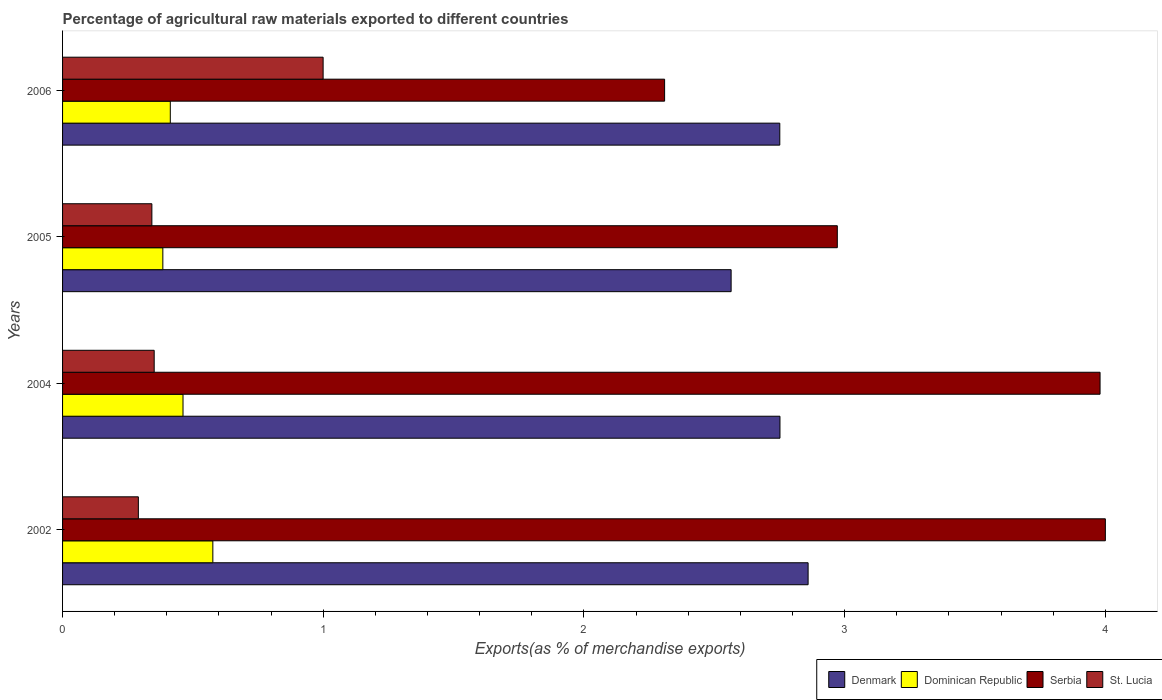How many different coloured bars are there?
Give a very brief answer. 4. Are the number of bars on each tick of the Y-axis equal?
Keep it short and to the point. Yes. How many bars are there on the 1st tick from the top?
Give a very brief answer. 4. What is the label of the 4th group of bars from the top?
Your answer should be compact. 2002. What is the percentage of exports to different countries in Dominican Republic in 2006?
Offer a very short reply. 0.41. Across all years, what is the maximum percentage of exports to different countries in Dominican Republic?
Provide a succinct answer. 0.58. Across all years, what is the minimum percentage of exports to different countries in Denmark?
Provide a short and direct response. 2.56. In which year was the percentage of exports to different countries in Serbia maximum?
Provide a succinct answer. 2002. In which year was the percentage of exports to different countries in Serbia minimum?
Give a very brief answer. 2006. What is the total percentage of exports to different countries in Serbia in the graph?
Offer a very short reply. 13.26. What is the difference between the percentage of exports to different countries in Serbia in 2004 and that in 2006?
Your answer should be very brief. 1.67. What is the difference between the percentage of exports to different countries in Dominican Republic in 2005 and the percentage of exports to different countries in St. Lucia in 2002?
Make the answer very short. 0.09. What is the average percentage of exports to different countries in Dominican Republic per year?
Keep it short and to the point. 0.46. In the year 2004, what is the difference between the percentage of exports to different countries in Dominican Republic and percentage of exports to different countries in St. Lucia?
Make the answer very short. 0.11. What is the ratio of the percentage of exports to different countries in St. Lucia in 2002 to that in 2004?
Provide a short and direct response. 0.83. Is the percentage of exports to different countries in Dominican Republic in 2004 less than that in 2005?
Keep it short and to the point. No. What is the difference between the highest and the second highest percentage of exports to different countries in Denmark?
Your answer should be compact. 0.11. What is the difference between the highest and the lowest percentage of exports to different countries in Serbia?
Make the answer very short. 1.69. What does the 1st bar from the top in 2006 represents?
Your answer should be very brief. St. Lucia. Is it the case that in every year, the sum of the percentage of exports to different countries in Denmark and percentage of exports to different countries in Serbia is greater than the percentage of exports to different countries in Dominican Republic?
Your answer should be compact. Yes. Are all the bars in the graph horizontal?
Your response must be concise. Yes. How many years are there in the graph?
Your answer should be very brief. 4. Are the values on the major ticks of X-axis written in scientific E-notation?
Provide a short and direct response. No. Does the graph contain any zero values?
Your response must be concise. No. Does the graph contain grids?
Keep it short and to the point. No. Where does the legend appear in the graph?
Your answer should be very brief. Bottom right. How many legend labels are there?
Offer a very short reply. 4. How are the legend labels stacked?
Keep it short and to the point. Horizontal. What is the title of the graph?
Keep it short and to the point. Percentage of agricultural raw materials exported to different countries. What is the label or title of the X-axis?
Your answer should be very brief. Exports(as % of merchandise exports). What is the label or title of the Y-axis?
Your answer should be compact. Years. What is the Exports(as % of merchandise exports) of Denmark in 2002?
Offer a very short reply. 2.86. What is the Exports(as % of merchandise exports) in Dominican Republic in 2002?
Give a very brief answer. 0.58. What is the Exports(as % of merchandise exports) in Serbia in 2002?
Keep it short and to the point. 4. What is the Exports(as % of merchandise exports) of St. Lucia in 2002?
Offer a terse response. 0.29. What is the Exports(as % of merchandise exports) in Denmark in 2004?
Ensure brevity in your answer.  2.75. What is the Exports(as % of merchandise exports) of Dominican Republic in 2004?
Your answer should be compact. 0.46. What is the Exports(as % of merchandise exports) of Serbia in 2004?
Offer a very short reply. 3.98. What is the Exports(as % of merchandise exports) of St. Lucia in 2004?
Make the answer very short. 0.35. What is the Exports(as % of merchandise exports) in Denmark in 2005?
Your response must be concise. 2.56. What is the Exports(as % of merchandise exports) of Dominican Republic in 2005?
Your answer should be very brief. 0.38. What is the Exports(as % of merchandise exports) of Serbia in 2005?
Offer a very short reply. 2.97. What is the Exports(as % of merchandise exports) in St. Lucia in 2005?
Your answer should be very brief. 0.34. What is the Exports(as % of merchandise exports) in Denmark in 2006?
Keep it short and to the point. 2.75. What is the Exports(as % of merchandise exports) of Dominican Republic in 2006?
Make the answer very short. 0.41. What is the Exports(as % of merchandise exports) of Serbia in 2006?
Keep it short and to the point. 2.31. What is the Exports(as % of merchandise exports) of St. Lucia in 2006?
Make the answer very short. 1. Across all years, what is the maximum Exports(as % of merchandise exports) of Denmark?
Give a very brief answer. 2.86. Across all years, what is the maximum Exports(as % of merchandise exports) in Dominican Republic?
Ensure brevity in your answer.  0.58. Across all years, what is the maximum Exports(as % of merchandise exports) of Serbia?
Your answer should be compact. 4. Across all years, what is the maximum Exports(as % of merchandise exports) of St. Lucia?
Provide a short and direct response. 1. Across all years, what is the minimum Exports(as % of merchandise exports) of Denmark?
Your response must be concise. 2.56. Across all years, what is the minimum Exports(as % of merchandise exports) in Dominican Republic?
Give a very brief answer. 0.38. Across all years, what is the minimum Exports(as % of merchandise exports) in Serbia?
Offer a very short reply. 2.31. Across all years, what is the minimum Exports(as % of merchandise exports) of St. Lucia?
Offer a terse response. 0.29. What is the total Exports(as % of merchandise exports) in Denmark in the graph?
Your answer should be very brief. 10.93. What is the total Exports(as % of merchandise exports) in Dominican Republic in the graph?
Offer a very short reply. 1.84. What is the total Exports(as % of merchandise exports) in Serbia in the graph?
Provide a succinct answer. 13.26. What is the total Exports(as % of merchandise exports) in St. Lucia in the graph?
Keep it short and to the point. 1.98. What is the difference between the Exports(as % of merchandise exports) of Denmark in 2002 and that in 2004?
Offer a terse response. 0.11. What is the difference between the Exports(as % of merchandise exports) in Dominican Republic in 2002 and that in 2004?
Offer a terse response. 0.11. What is the difference between the Exports(as % of merchandise exports) in Serbia in 2002 and that in 2004?
Offer a very short reply. 0.02. What is the difference between the Exports(as % of merchandise exports) in St. Lucia in 2002 and that in 2004?
Give a very brief answer. -0.06. What is the difference between the Exports(as % of merchandise exports) of Denmark in 2002 and that in 2005?
Your response must be concise. 0.3. What is the difference between the Exports(as % of merchandise exports) in Dominican Republic in 2002 and that in 2005?
Offer a very short reply. 0.19. What is the difference between the Exports(as % of merchandise exports) in Serbia in 2002 and that in 2005?
Offer a very short reply. 1.03. What is the difference between the Exports(as % of merchandise exports) in St. Lucia in 2002 and that in 2005?
Give a very brief answer. -0.05. What is the difference between the Exports(as % of merchandise exports) in Denmark in 2002 and that in 2006?
Keep it short and to the point. 0.11. What is the difference between the Exports(as % of merchandise exports) in Dominican Republic in 2002 and that in 2006?
Offer a terse response. 0.16. What is the difference between the Exports(as % of merchandise exports) of Serbia in 2002 and that in 2006?
Your response must be concise. 1.69. What is the difference between the Exports(as % of merchandise exports) in St. Lucia in 2002 and that in 2006?
Give a very brief answer. -0.71. What is the difference between the Exports(as % of merchandise exports) in Denmark in 2004 and that in 2005?
Provide a succinct answer. 0.19. What is the difference between the Exports(as % of merchandise exports) in Dominican Republic in 2004 and that in 2005?
Offer a terse response. 0.08. What is the difference between the Exports(as % of merchandise exports) of Serbia in 2004 and that in 2005?
Offer a very short reply. 1.01. What is the difference between the Exports(as % of merchandise exports) of St. Lucia in 2004 and that in 2005?
Your response must be concise. 0.01. What is the difference between the Exports(as % of merchandise exports) of Denmark in 2004 and that in 2006?
Keep it short and to the point. 0. What is the difference between the Exports(as % of merchandise exports) in Dominican Republic in 2004 and that in 2006?
Ensure brevity in your answer.  0.05. What is the difference between the Exports(as % of merchandise exports) in Serbia in 2004 and that in 2006?
Provide a succinct answer. 1.67. What is the difference between the Exports(as % of merchandise exports) of St. Lucia in 2004 and that in 2006?
Your answer should be very brief. -0.65. What is the difference between the Exports(as % of merchandise exports) in Denmark in 2005 and that in 2006?
Your response must be concise. -0.19. What is the difference between the Exports(as % of merchandise exports) in Dominican Republic in 2005 and that in 2006?
Provide a short and direct response. -0.03. What is the difference between the Exports(as % of merchandise exports) in Serbia in 2005 and that in 2006?
Make the answer very short. 0.66. What is the difference between the Exports(as % of merchandise exports) in St. Lucia in 2005 and that in 2006?
Offer a very short reply. -0.66. What is the difference between the Exports(as % of merchandise exports) in Denmark in 2002 and the Exports(as % of merchandise exports) in Dominican Republic in 2004?
Offer a terse response. 2.4. What is the difference between the Exports(as % of merchandise exports) of Denmark in 2002 and the Exports(as % of merchandise exports) of Serbia in 2004?
Keep it short and to the point. -1.12. What is the difference between the Exports(as % of merchandise exports) in Denmark in 2002 and the Exports(as % of merchandise exports) in St. Lucia in 2004?
Offer a terse response. 2.51. What is the difference between the Exports(as % of merchandise exports) in Dominican Republic in 2002 and the Exports(as % of merchandise exports) in Serbia in 2004?
Offer a very short reply. -3.4. What is the difference between the Exports(as % of merchandise exports) of Dominican Republic in 2002 and the Exports(as % of merchandise exports) of St. Lucia in 2004?
Give a very brief answer. 0.23. What is the difference between the Exports(as % of merchandise exports) in Serbia in 2002 and the Exports(as % of merchandise exports) in St. Lucia in 2004?
Offer a terse response. 3.65. What is the difference between the Exports(as % of merchandise exports) of Denmark in 2002 and the Exports(as % of merchandise exports) of Dominican Republic in 2005?
Make the answer very short. 2.48. What is the difference between the Exports(as % of merchandise exports) in Denmark in 2002 and the Exports(as % of merchandise exports) in Serbia in 2005?
Your answer should be compact. -0.11. What is the difference between the Exports(as % of merchandise exports) of Denmark in 2002 and the Exports(as % of merchandise exports) of St. Lucia in 2005?
Offer a very short reply. 2.52. What is the difference between the Exports(as % of merchandise exports) in Dominican Republic in 2002 and the Exports(as % of merchandise exports) in Serbia in 2005?
Provide a succinct answer. -2.4. What is the difference between the Exports(as % of merchandise exports) in Dominican Republic in 2002 and the Exports(as % of merchandise exports) in St. Lucia in 2005?
Offer a very short reply. 0.23. What is the difference between the Exports(as % of merchandise exports) of Serbia in 2002 and the Exports(as % of merchandise exports) of St. Lucia in 2005?
Ensure brevity in your answer.  3.66. What is the difference between the Exports(as % of merchandise exports) of Denmark in 2002 and the Exports(as % of merchandise exports) of Dominican Republic in 2006?
Make the answer very short. 2.45. What is the difference between the Exports(as % of merchandise exports) in Denmark in 2002 and the Exports(as % of merchandise exports) in Serbia in 2006?
Provide a short and direct response. 0.55. What is the difference between the Exports(as % of merchandise exports) in Denmark in 2002 and the Exports(as % of merchandise exports) in St. Lucia in 2006?
Your answer should be very brief. 1.86. What is the difference between the Exports(as % of merchandise exports) in Dominican Republic in 2002 and the Exports(as % of merchandise exports) in Serbia in 2006?
Make the answer very short. -1.73. What is the difference between the Exports(as % of merchandise exports) of Dominican Republic in 2002 and the Exports(as % of merchandise exports) of St. Lucia in 2006?
Offer a terse response. -0.42. What is the difference between the Exports(as % of merchandise exports) of Serbia in 2002 and the Exports(as % of merchandise exports) of St. Lucia in 2006?
Your answer should be compact. 3. What is the difference between the Exports(as % of merchandise exports) of Denmark in 2004 and the Exports(as % of merchandise exports) of Dominican Republic in 2005?
Keep it short and to the point. 2.37. What is the difference between the Exports(as % of merchandise exports) in Denmark in 2004 and the Exports(as % of merchandise exports) in Serbia in 2005?
Make the answer very short. -0.22. What is the difference between the Exports(as % of merchandise exports) of Denmark in 2004 and the Exports(as % of merchandise exports) of St. Lucia in 2005?
Ensure brevity in your answer.  2.41. What is the difference between the Exports(as % of merchandise exports) of Dominican Republic in 2004 and the Exports(as % of merchandise exports) of Serbia in 2005?
Keep it short and to the point. -2.51. What is the difference between the Exports(as % of merchandise exports) of Dominican Republic in 2004 and the Exports(as % of merchandise exports) of St. Lucia in 2005?
Keep it short and to the point. 0.12. What is the difference between the Exports(as % of merchandise exports) in Serbia in 2004 and the Exports(as % of merchandise exports) in St. Lucia in 2005?
Provide a short and direct response. 3.64. What is the difference between the Exports(as % of merchandise exports) in Denmark in 2004 and the Exports(as % of merchandise exports) in Dominican Republic in 2006?
Offer a terse response. 2.34. What is the difference between the Exports(as % of merchandise exports) of Denmark in 2004 and the Exports(as % of merchandise exports) of Serbia in 2006?
Ensure brevity in your answer.  0.44. What is the difference between the Exports(as % of merchandise exports) in Denmark in 2004 and the Exports(as % of merchandise exports) in St. Lucia in 2006?
Ensure brevity in your answer.  1.75. What is the difference between the Exports(as % of merchandise exports) in Dominican Republic in 2004 and the Exports(as % of merchandise exports) in Serbia in 2006?
Your answer should be compact. -1.85. What is the difference between the Exports(as % of merchandise exports) of Dominican Republic in 2004 and the Exports(as % of merchandise exports) of St. Lucia in 2006?
Provide a succinct answer. -0.54. What is the difference between the Exports(as % of merchandise exports) in Serbia in 2004 and the Exports(as % of merchandise exports) in St. Lucia in 2006?
Your answer should be very brief. 2.98. What is the difference between the Exports(as % of merchandise exports) in Denmark in 2005 and the Exports(as % of merchandise exports) in Dominican Republic in 2006?
Ensure brevity in your answer.  2.15. What is the difference between the Exports(as % of merchandise exports) in Denmark in 2005 and the Exports(as % of merchandise exports) in Serbia in 2006?
Your answer should be very brief. 0.26. What is the difference between the Exports(as % of merchandise exports) of Denmark in 2005 and the Exports(as % of merchandise exports) of St. Lucia in 2006?
Your response must be concise. 1.56. What is the difference between the Exports(as % of merchandise exports) in Dominican Republic in 2005 and the Exports(as % of merchandise exports) in Serbia in 2006?
Keep it short and to the point. -1.92. What is the difference between the Exports(as % of merchandise exports) in Dominican Republic in 2005 and the Exports(as % of merchandise exports) in St. Lucia in 2006?
Give a very brief answer. -0.61. What is the difference between the Exports(as % of merchandise exports) in Serbia in 2005 and the Exports(as % of merchandise exports) in St. Lucia in 2006?
Your answer should be compact. 1.97. What is the average Exports(as % of merchandise exports) of Denmark per year?
Give a very brief answer. 2.73. What is the average Exports(as % of merchandise exports) in Dominican Republic per year?
Keep it short and to the point. 0.46. What is the average Exports(as % of merchandise exports) of Serbia per year?
Offer a terse response. 3.32. What is the average Exports(as % of merchandise exports) in St. Lucia per year?
Keep it short and to the point. 0.5. In the year 2002, what is the difference between the Exports(as % of merchandise exports) in Denmark and Exports(as % of merchandise exports) in Dominican Republic?
Keep it short and to the point. 2.28. In the year 2002, what is the difference between the Exports(as % of merchandise exports) of Denmark and Exports(as % of merchandise exports) of Serbia?
Your answer should be compact. -1.14. In the year 2002, what is the difference between the Exports(as % of merchandise exports) in Denmark and Exports(as % of merchandise exports) in St. Lucia?
Your response must be concise. 2.57. In the year 2002, what is the difference between the Exports(as % of merchandise exports) of Dominican Republic and Exports(as % of merchandise exports) of Serbia?
Make the answer very short. -3.42. In the year 2002, what is the difference between the Exports(as % of merchandise exports) in Dominican Republic and Exports(as % of merchandise exports) in St. Lucia?
Ensure brevity in your answer.  0.29. In the year 2002, what is the difference between the Exports(as % of merchandise exports) in Serbia and Exports(as % of merchandise exports) in St. Lucia?
Make the answer very short. 3.71. In the year 2004, what is the difference between the Exports(as % of merchandise exports) in Denmark and Exports(as % of merchandise exports) in Dominican Republic?
Offer a very short reply. 2.29. In the year 2004, what is the difference between the Exports(as % of merchandise exports) of Denmark and Exports(as % of merchandise exports) of Serbia?
Make the answer very short. -1.23. In the year 2004, what is the difference between the Exports(as % of merchandise exports) in Denmark and Exports(as % of merchandise exports) in St. Lucia?
Provide a short and direct response. 2.4. In the year 2004, what is the difference between the Exports(as % of merchandise exports) of Dominican Republic and Exports(as % of merchandise exports) of Serbia?
Your response must be concise. -3.52. In the year 2004, what is the difference between the Exports(as % of merchandise exports) in Dominican Republic and Exports(as % of merchandise exports) in St. Lucia?
Offer a very short reply. 0.11. In the year 2004, what is the difference between the Exports(as % of merchandise exports) of Serbia and Exports(as % of merchandise exports) of St. Lucia?
Ensure brevity in your answer.  3.63. In the year 2005, what is the difference between the Exports(as % of merchandise exports) of Denmark and Exports(as % of merchandise exports) of Dominican Republic?
Your answer should be very brief. 2.18. In the year 2005, what is the difference between the Exports(as % of merchandise exports) of Denmark and Exports(as % of merchandise exports) of Serbia?
Provide a short and direct response. -0.41. In the year 2005, what is the difference between the Exports(as % of merchandise exports) in Denmark and Exports(as % of merchandise exports) in St. Lucia?
Offer a very short reply. 2.22. In the year 2005, what is the difference between the Exports(as % of merchandise exports) in Dominican Republic and Exports(as % of merchandise exports) in Serbia?
Make the answer very short. -2.59. In the year 2005, what is the difference between the Exports(as % of merchandise exports) of Dominican Republic and Exports(as % of merchandise exports) of St. Lucia?
Offer a terse response. 0.04. In the year 2005, what is the difference between the Exports(as % of merchandise exports) in Serbia and Exports(as % of merchandise exports) in St. Lucia?
Your answer should be compact. 2.63. In the year 2006, what is the difference between the Exports(as % of merchandise exports) of Denmark and Exports(as % of merchandise exports) of Dominican Republic?
Provide a short and direct response. 2.34. In the year 2006, what is the difference between the Exports(as % of merchandise exports) in Denmark and Exports(as % of merchandise exports) in Serbia?
Your answer should be compact. 0.44. In the year 2006, what is the difference between the Exports(as % of merchandise exports) in Denmark and Exports(as % of merchandise exports) in St. Lucia?
Give a very brief answer. 1.75. In the year 2006, what is the difference between the Exports(as % of merchandise exports) of Dominican Republic and Exports(as % of merchandise exports) of Serbia?
Keep it short and to the point. -1.9. In the year 2006, what is the difference between the Exports(as % of merchandise exports) of Dominican Republic and Exports(as % of merchandise exports) of St. Lucia?
Provide a succinct answer. -0.59. In the year 2006, what is the difference between the Exports(as % of merchandise exports) of Serbia and Exports(as % of merchandise exports) of St. Lucia?
Offer a terse response. 1.31. What is the ratio of the Exports(as % of merchandise exports) in Denmark in 2002 to that in 2004?
Give a very brief answer. 1.04. What is the ratio of the Exports(as % of merchandise exports) of Dominican Republic in 2002 to that in 2004?
Keep it short and to the point. 1.25. What is the ratio of the Exports(as % of merchandise exports) of St. Lucia in 2002 to that in 2004?
Your response must be concise. 0.83. What is the ratio of the Exports(as % of merchandise exports) in Denmark in 2002 to that in 2005?
Provide a succinct answer. 1.12. What is the ratio of the Exports(as % of merchandise exports) in Dominican Republic in 2002 to that in 2005?
Provide a short and direct response. 1.5. What is the ratio of the Exports(as % of merchandise exports) in Serbia in 2002 to that in 2005?
Your response must be concise. 1.35. What is the ratio of the Exports(as % of merchandise exports) in St. Lucia in 2002 to that in 2005?
Keep it short and to the point. 0.85. What is the ratio of the Exports(as % of merchandise exports) of Denmark in 2002 to that in 2006?
Give a very brief answer. 1.04. What is the ratio of the Exports(as % of merchandise exports) of Dominican Republic in 2002 to that in 2006?
Give a very brief answer. 1.39. What is the ratio of the Exports(as % of merchandise exports) in Serbia in 2002 to that in 2006?
Offer a very short reply. 1.73. What is the ratio of the Exports(as % of merchandise exports) in St. Lucia in 2002 to that in 2006?
Offer a very short reply. 0.29. What is the ratio of the Exports(as % of merchandise exports) in Denmark in 2004 to that in 2005?
Make the answer very short. 1.07. What is the ratio of the Exports(as % of merchandise exports) of Dominican Republic in 2004 to that in 2005?
Make the answer very short. 1.2. What is the ratio of the Exports(as % of merchandise exports) in Serbia in 2004 to that in 2005?
Provide a succinct answer. 1.34. What is the ratio of the Exports(as % of merchandise exports) of St. Lucia in 2004 to that in 2005?
Your response must be concise. 1.03. What is the ratio of the Exports(as % of merchandise exports) of Dominican Republic in 2004 to that in 2006?
Your answer should be very brief. 1.12. What is the ratio of the Exports(as % of merchandise exports) of Serbia in 2004 to that in 2006?
Ensure brevity in your answer.  1.72. What is the ratio of the Exports(as % of merchandise exports) of St. Lucia in 2004 to that in 2006?
Keep it short and to the point. 0.35. What is the ratio of the Exports(as % of merchandise exports) of Denmark in 2005 to that in 2006?
Keep it short and to the point. 0.93. What is the ratio of the Exports(as % of merchandise exports) in Dominican Republic in 2005 to that in 2006?
Ensure brevity in your answer.  0.93. What is the ratio of the Exports(as % of merchandise exports) in Serbia in 2005 to that in 2006?
Offer a terse response. 1.29. What is the ratio of the Exports(as % of merchandise exports) in St. Lucia in 2005 to that in 2006?
Ensure brevity in your answer.  0.34. What is the difference between the highest and the second highest Exports(as % of merchandise exports) in Denmark?
Offer a very short reply. 0.11. What is the difference between the highest and the second highest Exports(as % of merchandise exports) of Dominican Republic?
Provide a short and direct response. 0.11. What is the difference between the highest and the second highest Exports(as % of merchandise exports) in Serbia?
Provide a short and direct response. 0.02. What is the difference between the highest and the second highest Exports(as % of merchandise exports) in St. Lucia?
Offer a very short reply. 0.65. What is the difference between the highest and the lowest Exports(as % of merchandise exports) of Denmark?
Offer a terse response. 0.3. What is the difference between the highest and the lowest Exports(as % of merchandise exports) of Dominican Republic?
Offer a very short reply. 0.19. What is the difference between the highest and the lowest Exports(as % of merchandise exports) in Serbia?
Your response must be concise. 1.69. What is the difference between the highest and the lowest Exports(as % of merchandise exports) of St. Lucia?
Provide a succinct answer. 0.71. 